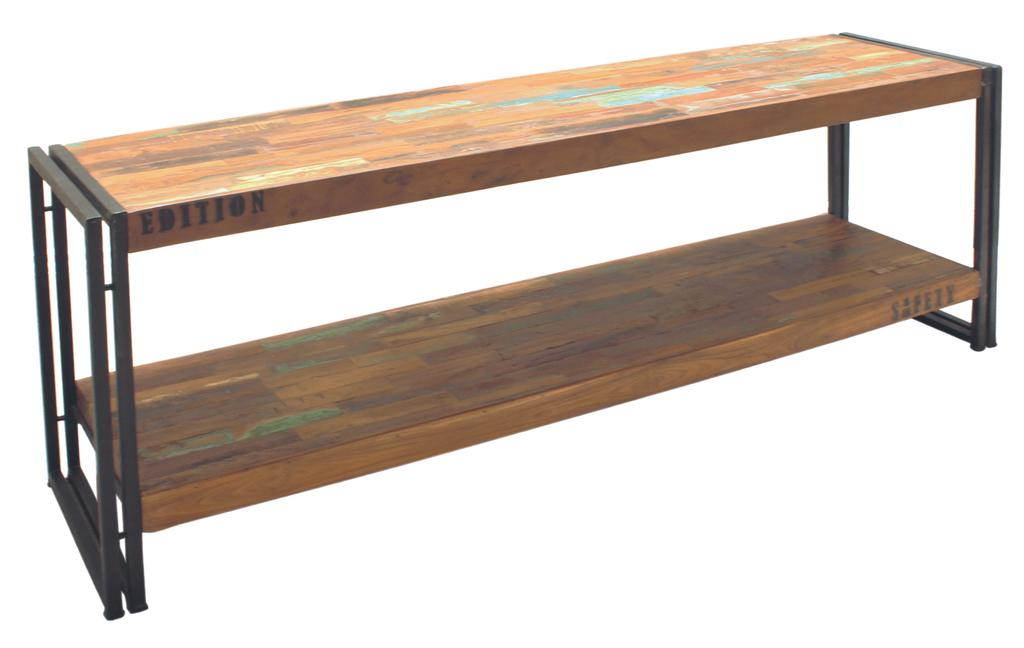<image>
Write a terse but informative summary of the picture. Two wooden shelfs with "Edition" and "Safety" stamped on the edges. 